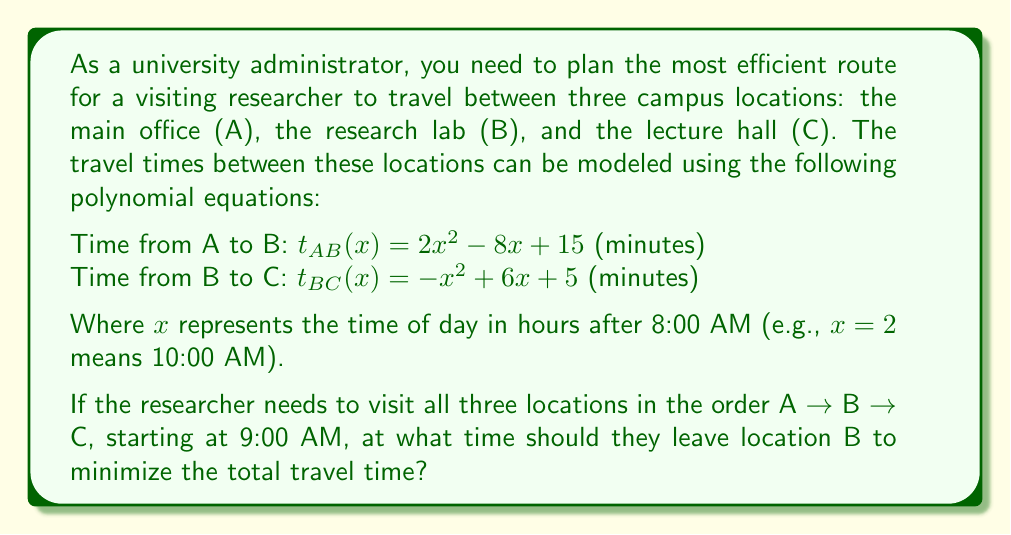Give your solution to this math problem. Let's approach this problem step by step:

1) First, we need to calculate the time it takes to go from A to B, starting at 9:00 AM.
   At 9:00 AM, $x = 1$ (1 hour after 8:00 AM)
   $t_{AB}(1) = 2(1)^2 - 8(1) + 15 = 2 - 8 + 15 = 9$ minutes

2) Now, we need to find the minimum time for the journey from B to C.
   To do this, we need to find the minimum of the function $t_{BC}(x) = -x^2 + 6x + 5$

3) To find the minimum, we differentiate $t_{BC}(x)$ and set it to zero:
   $\frac{d}{dx}t_{BC}(x) = -2x + 6$
   $-2x + 6 = 0$
   $-2x = -6$
   $x = 3$

4) The second derivative is negative ($-2$), confirming this is a maximum.
   Therefore, the minimum occurs at the edges of our domain.

5) We need to consider the domain of $x$. The researcher arrives at B at 9:09 AM, 
   which is $x = 1.15$ hours after 8:00 AM.

6) Let's calculate $t_{BC}(x)$ for $x = 1.15$ and for the end of the day, say $x = 8$ (4:00 PM):
   $t_{BC}(1.15) = -(1.15)^2 + 6(1.15) + 5 = 10.7775$ minutes
   $t_{BC}(8) = -(8)^2 + 6(8) + 5 = -11$ minutes (which is not possible in reality)

7) Therefore, the minimum travel time occurs when leaving immediately upon arrival at B.
Answer: 9:09 AM 